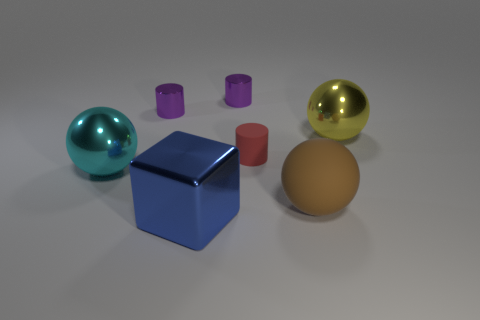There is a purple shiny object that is on the right side of the blue block; is it the same shape as the tiny red object?
Offer a terse response. Yes. What number of other objects are there of the same shape as the big brown rubber thing?
Give a very brief answer. 2. What is the shape of the matte thing behind the large brown object?
Provide a succinct answer. Cylinder. Is there a purple thing made of the same material as the blue object?
Keep it short and to the point. Yes. Is the color of the metallic object that is on the right side of the brown thing the same as the block?
Offer a terse response. No. The cyan metallic thing has what size?
Offer a terse response. Large. Is there a large thing in front of the large shiny ball that is in front of the large shiny thing behind the large cyan shiny sphere?
Provide a succinct answer. Yes. There is a big brown matte thing; how many metallic objects are to the left of it?
Your response must be concise. 4. What number of things are metal objects that are behind the matte cylinder or small objects to the left of the tiny red thing?
Your answer should be very brief. 3. Is the number of cyan objects greater than the number of small green things?
Keep it short and to the point. Yes. 